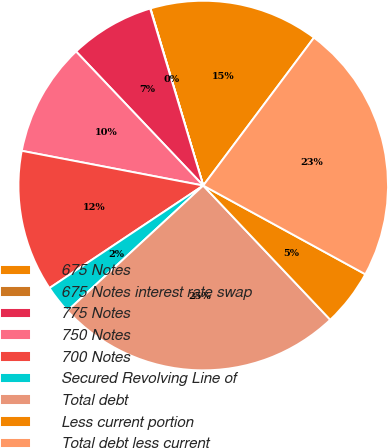<chart> <loc_0><loc_0><loc_500><loc_500><pie_chart><fcel>675 Notes<fcel>675 Notes interest rate swap<fcel>775 Notes<fcel>750 Notes<fcel>700 Notes<fcel>Secured Revolving Line of<fcel>Total debt<fcel>Less current portion<fcel>Total debt less current<nl><fcel>14.84%<fcel>0.03%<fcel>7.44%<fcel>9.91%<fcel>12.37%<fcel>2.5%<fcel>25.2%<fcel>4.97%<fcel>22.74%<nl></chart> 